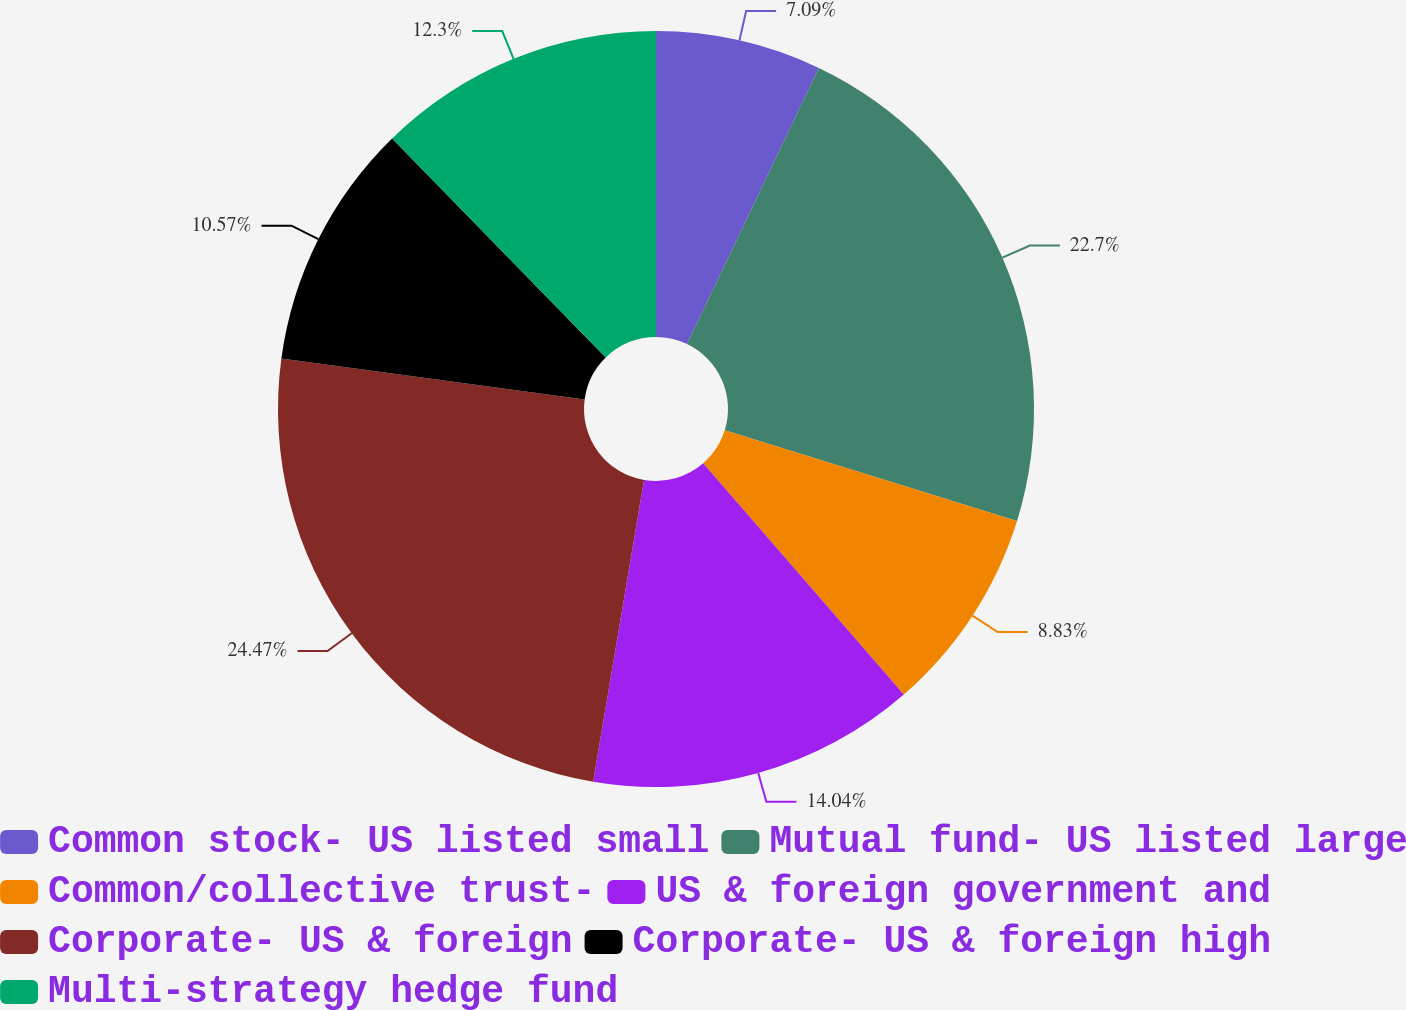<chart> <loc_0><loc_0><loc_500><loc_500><pie_chart><fcel>Common stock- US listed small<fcel>Mutual fund- US listed large<fcel>Common/collective trust-<fcel>US & foreign government and<fcel>Corporate- US & foreign<fcel>Corporate- US & foreign high<fcel>Multi-strategy hedge fund<nl><fcel>7.09%<fcel>22.7%<fcel>8.83%<fcel>14.04%<fcel>24.47%<fcel>10.57%<fcel>12.3%<nl></chart> 